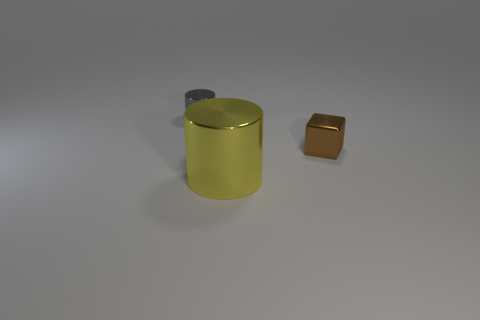Add 2 yellow objects. How many objects exist? 5 Subtract all cubes. How many objects are left? 2 Subtract 0 purple blocks. How many objects are left? 3 Subtract all tiny purple metal things. Subtract all brown objects. How many objects are left? 2 Add 1 yellow things. How many yellow things are left? 2 Add 1 tiny cubes. How many tiny cubes exist? 2 